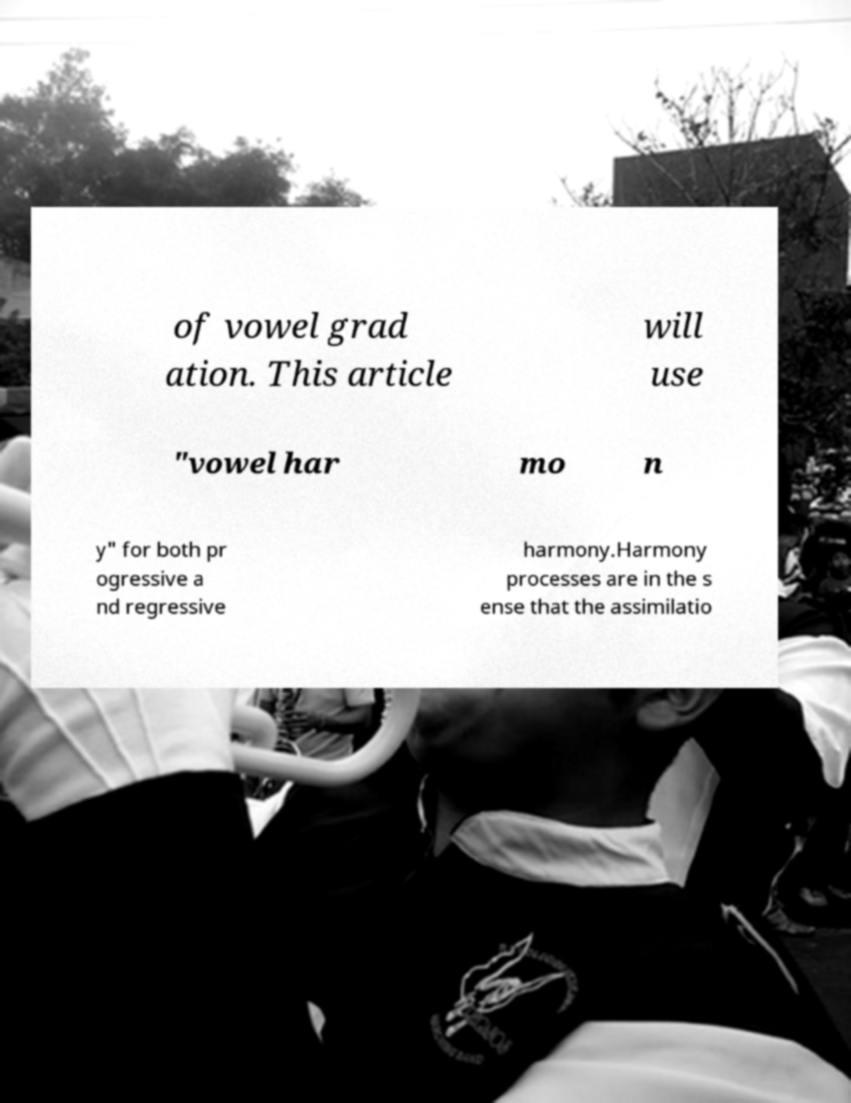Could you extract and type out the text from this image? of vowel grad ation. This article will use "vowel har mo n y" for both pr ogressive a nd regressive harmony.Harmony processes are in the s ense that the assimilatio 